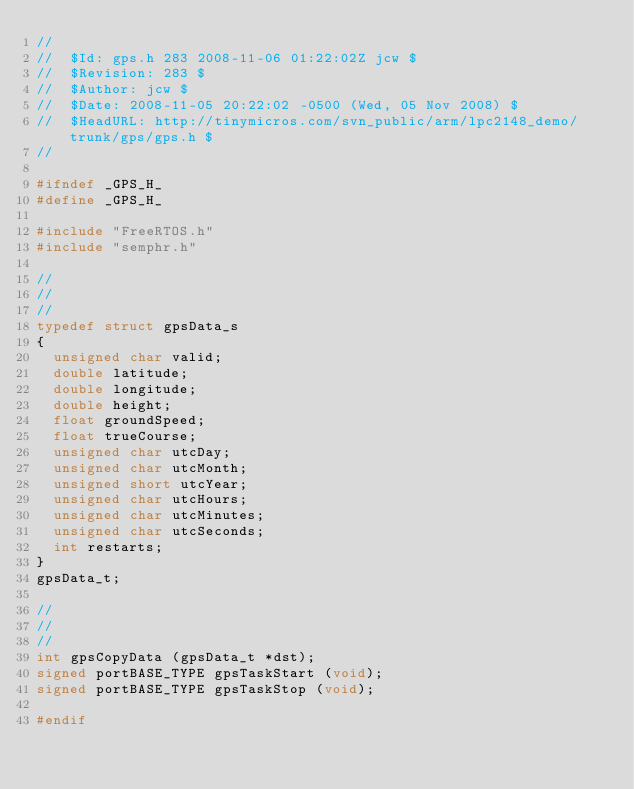<code> <loc_0><loc_0><loc_500><loc_500><_C_>//
//  $Id: gps.h 283 2008-11-06 01:22:02Z jcw $
//  $Revision: 283 $
//  $Author: jcw $
//  $Date: 2008-11-05 20:22:02 -0500 (Wed, 05 Nov 2008) $
//  $HeadURL: http://tinymicros.com/svn_public/arm/lpc2148_demo/trunk/gps/gps.h $
//

#ifndef _GPS_H_
#define _GPS_H_

#include "FreeRTOS.h"
#include "semphr.h"

//
//
//
typedef struct gpsData_s
{
  unsigned char valid;
  double latitude;
  double longitude;
  double height;
  float groundSpeed;
  float trueCourse;
  unsigned char utcDay;
  unsigned char utcMonth;
  unsigned short utcYear;
  unsigned char utcHours;
  unsigned char utcMinutes;
  unsigned char utcSeconds;
  int restarts;
}
gpsData_t;

//
//
//
int gpsCopyData (gpsData_t *dst);
signed portBASE_TYPE gpsTaskStart (void);
signed portBASE_TYPE gpsTaskStop (void);

#endif
</code> 